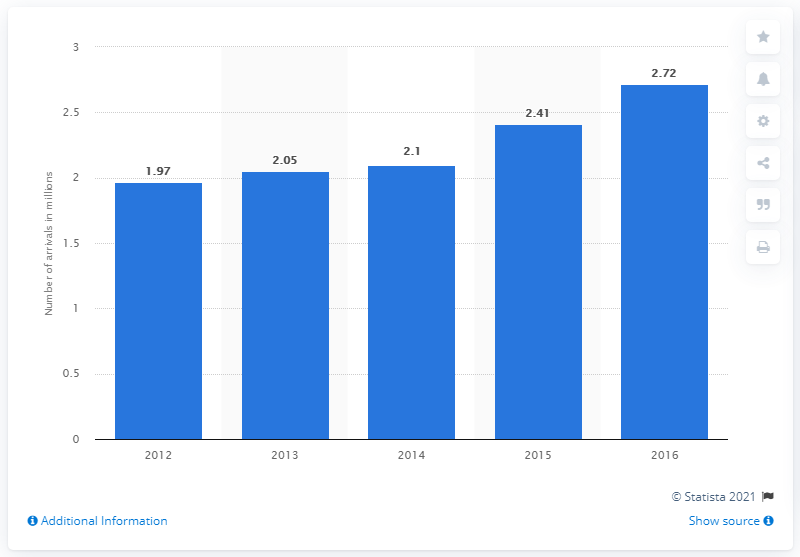Indicate a few pertinent items in this graphic. Between 2012 and 2016, a total of 2,720,000 tourist arrivals were recorded in Serbia. Between the year 2012, the number of tourist arrivals in Serbia increased. 